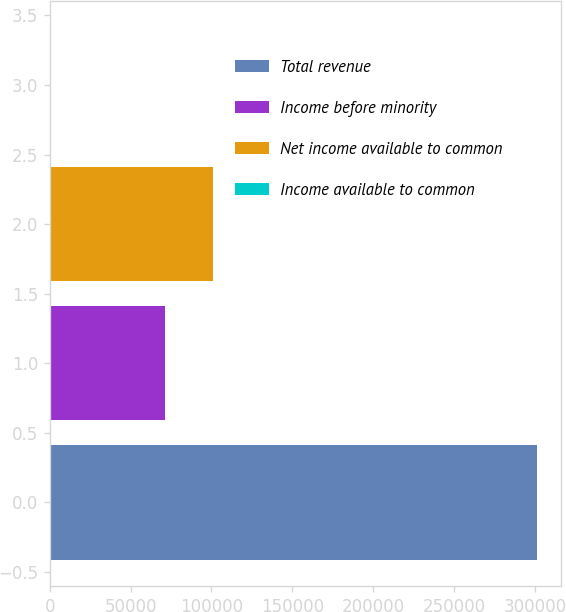Convert chart to OTSL. <chart><loc_0><loc_0><loc_500><loc_500><bar_chart><fcel>Total revenue<fcel>Income before minority<fcel>Net income available to common<fcel>Income available to common<nl><fcel>300971<fcel>71042<fcel>101139<fcel>0.74<nl></chart> 